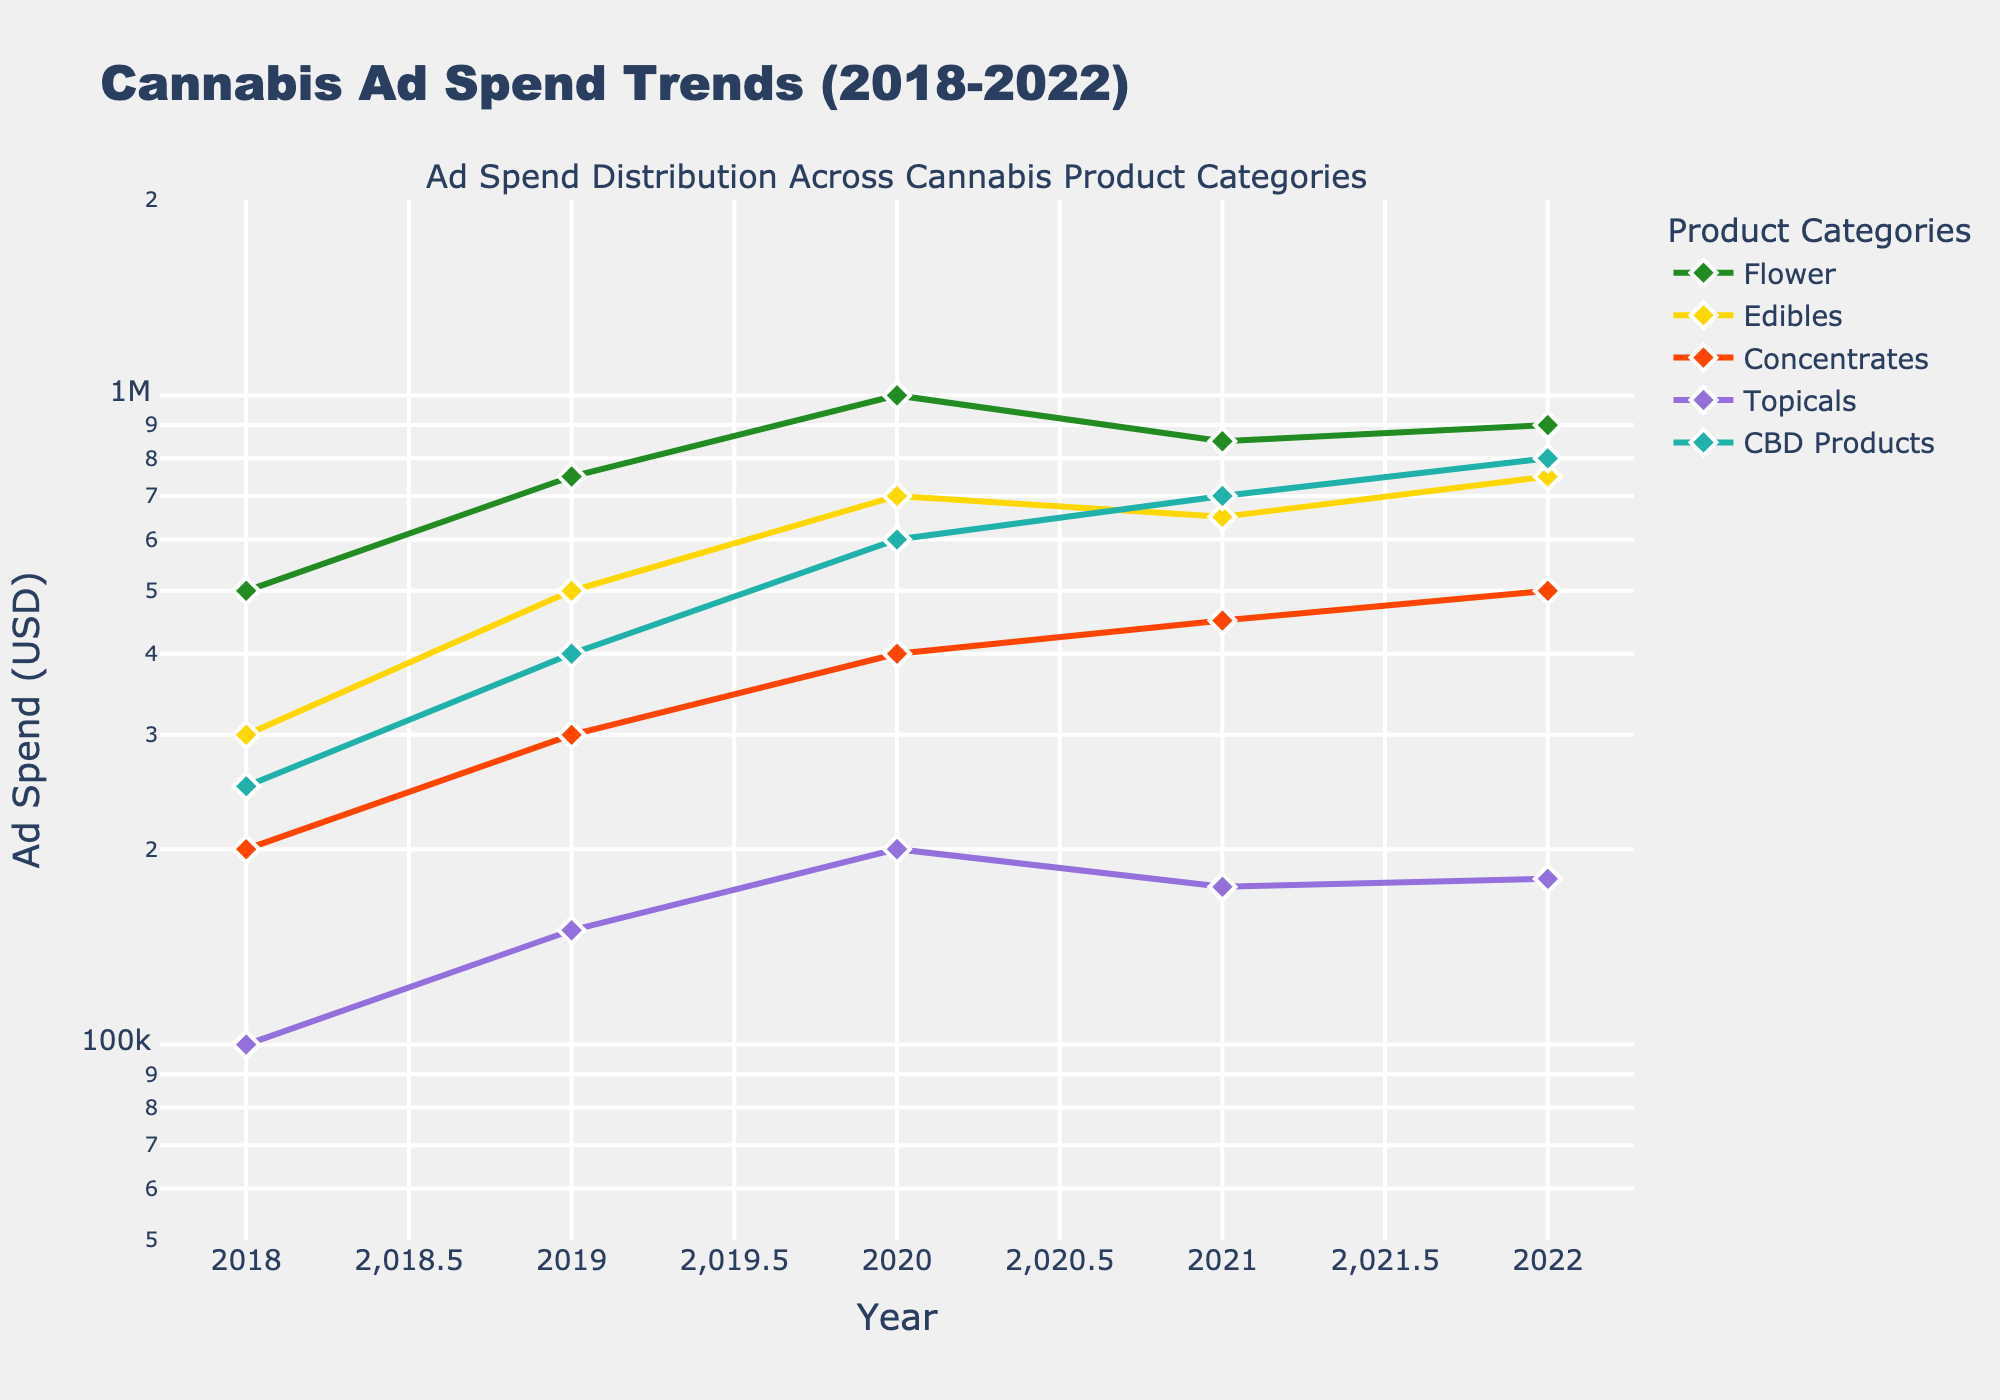How many years of data are shown in the plot? The x-axis of the plot shows the span of years. The data points range from 2018 to 2022.
Answer: 5 What is the trend in ad spend for Flower products from 2018 to 2022? By observing the line representing Flower products, it starts at 500,000 USD in 2018, peaks in 2020 at 1,000,000 USD, and slightly declines before stabilizing, ending at 900,000 USD in 2022.
Answer: Increase then slight decline Which product category had the highest ad spend in 2020? Look at the y-values of the different categories at the point corresponding to 2020. Flower has the highest ad spend among all categories at 1,000,000 USD.
Answer: Flower What is the percentage increase in ad spend for CBD Products from 2018 to 2022? The ad spend for CBD Products increases from 250,000 USD in 2018 to 800,000 USD in 2022. The formula for percentage increase is \[(800,000 - 250,000) / 250,000 * 100 = 220%\].
Answer: 220% How does the growth rate of Edibles compare to that of Concentrates from 2018 to 2022? The ad spend for Edibles increases from 300,000 USD to 750,000 USD, while Concentrates increase from 200,000 USD to 500,000 USD over the same period. Edibles have a higher growth rate from 300,000 to 750,000, which is a 150% increase, whereas Concentrates' growth is 150% (200,000 to 500,000). Therefore, the rate is similar.
Answer: Similar Between 2020 to 2021, which category shows the greatest decline in ad spend? Observe the slopes between 2020 and 2021. Flower sees the biggest drop from 1,000,000 USD to 850,000 USD, a decline of 150,000 USD.
Answer: Flower As of 2022, which product category has the lowest ad spend? By looking at the y-values of the points in 2022, Topicals have the lowest ad spend at 180,000 USD.
Answer: Topicals Which product categories saw their ad spend increase every year from 2018 to 2022? By examining each category's line, CBD Products and Topicals show a consistent increase in ad spend every year without any decline.
Answer: CBD Products and Topicals How does the ad spend distribution compare between 2022 and 2018? In 2018, Flower and Edibles have the highest ad spend, while Topicals have the lowest. By 2022, Flower remains high, but CBD Products show significant growth, trailing close to Flower, with Topicals still being the lowest but increased. The distribution shows a significant increase in ad spends for newer categories, especially CBD Products, while traditional categories like Flower maintain their spend.
Answer: Increased in newer categories like CBD Products; Flower and Edibles relatively stable Which category showed the smallest absolute increase in ad spend from 2018 to 2022? Calculate the difference for each category: Flower (900,000 - 500,000 = 400,000), Edibles (750,000 - 300,000 = 450,000), Concentrates (500,000 - 200,000 = 300,000), Topicals (180,000 - 100,000 = 80,000), CBD Products (800,000 - 250,000 = 550,000). Topicals have the smallest absolute increase of 80,000 USD.
Answer: Topicals 